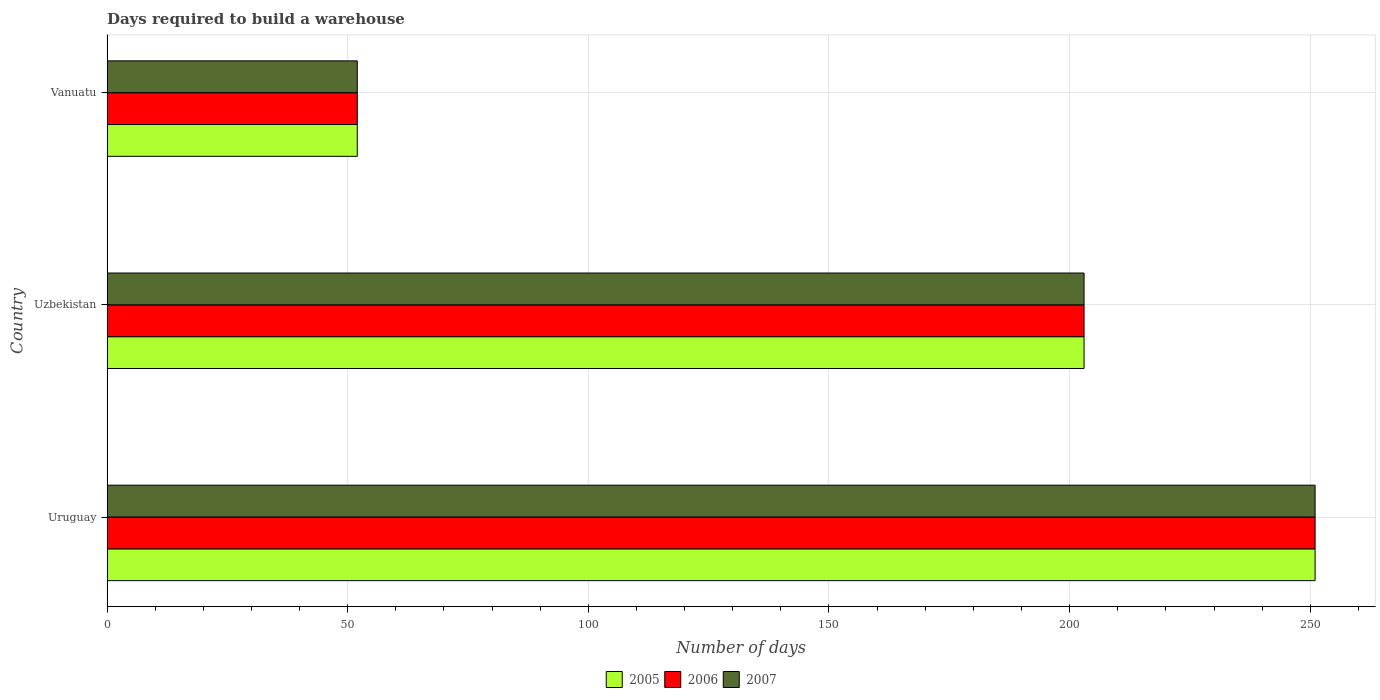How many different coloured bars are there?
Ensure brevity in your answer.  3. How many groups of bars are there?
Keep it short and to the point. 3. Are the number of bars per tick equal to the number of legend labels?
Your answer should be compact. Yes. Are the number of bars on each tick of the Y-axis equal?
Your answer should be very brief. Yes. What is the label of the 3rd group of bars from the top?
Offer a terse response. Uruguay. In how many cases, is the number of bars for a given country not equal to the number of legend labels?
Your answer should be very brief. 0. What is the days required to build a warehouse in in 2006 in Vanuatu?
Offer a terse response. 52. Across all countries, what is the maximum days required to build a warehouse in in 2006?
Keep it short and to the point. 251. In which country was the days required to build a warehouse in in 2005 maximum?
Your response must be concise. Uruguay. In which country was the days required to build a warehouse in in 2007 minimum?
Offer a terse response. Vanuatu. What is the total days required to build a warehouse in in 2006 in the graph?
Your response must be concise. 506. What is the difference between the days required to build a warehouse in in 2006 in Uruguay and that in Vanuatu?
Provide a short and direct response. 199. What is the difference between the days required to build a warehouse in in 2007 in Uruguay and the days required to build a warehouse in in 2005 in Vanuatu?
Offer a very short reply. 199. What is the average days required to build a warehouse in in 2005 per country?
Provide a succinct answer. 168.67. What is the ratio of the days required to build a warehouse in in 2005 in Uzbekistan to that in Vanuatu?
Offer a very short reply. 3.9. Is the difference between the days required to build a warehouse in in 2005 in Uzbekistan and Vanuatu greater than the difference between the days required to build a warehouse in in 2007 in Uzbekistan and Vanuatu?
Keep it short and to the point. No. What is the difference between the highest and the second highest days required to build a warehouse in in 2007?
Your answer should be compact. 48. What is the difference between the highest and the lowest days required to build a warehouse in in 2005?
Offer a terse response. 199. How many bars are there?
Your response must be concise. 9. Are all the bars in the graph horizontal?
Keep it short and to the point. Yes. How many countries are there in the graph?
Your answer should be very brief. 3. Does the graph contain any zero values?
Your answer should be very brief. No. What is the title of the graph?
Keep it short and to the point. Days required to build a warehouse. Does "2012" appear as one of the legend labels in the graph?
Keep it short and to the point. No. What is the label or title of the X-axis?
Offer a very short reply. Number of days. What is the Number of days of 2005 in Uruguay?
Make the answer very short. 251. What is the Number of days of 2006 in Uruguay?
Offer a terse response. 251. What is the Number of days of 2007 in Uruguay?
Ensure brevity in your answer.  251. What is the Number of days in 2005 in Uzbekistan?
Provide a succinct answer. 203. What is the Number of days in 2006 in Uzbekistan?
Your answer should be very brief. 203. What is the Number of days of 2007 in Uzbekistan?
Give a very brief answer. 203. What is the Number of days in 2005 in Vanuatu?
Your answer should be very brief. 52. What is the Number of days in 2006 in Vanuatu?
Your response must be concise. 52. What is the Number of days of 2007 in Vanuatu?
Make the answer very short. 52. Across all countries, what is the maximum Number of days of 2005?
Your answer should be compact. 251. Across all countries, what is the maximum Number of days of 2006?
Ensure brevity in your answer.  251. Across all countries, what is the maximum Number of days of 2007?
Your answer should be compact. 251. Across all countries, what is the minimum Number of days of 2005?
Keep it short and to the point. 52. Across all countries, what is the minimum Number of days in 2006?
Ensure brevity in your answer.  52. What is the total Number of days in 2005 in the graph?
Your answer should be compact. 506. What is the total Number of days of 2006 in the graph?
Provide a succinct answer. 506. What is the total Number of days of 2007 in the graph?
Your response must be concise. 506. What is the difference between the Number of days in 2005 in Uruguay and that in Vanuatu?
Your answer should be very brief. 199. What is the difference between the Number of days in 2006 in Uruguay and that in Vanuatu?
Your answer should be compact. 199. What is the difference between the Number of days of 2007 in Uruguay and that in Vanuatu?
Make the answer very short. 199. What is the difference between the Number of days in 2005 in Uzbekistan and that in Vanuatu?
Your response must be concise. 151. What is the difference between the Number of days in 2006 in Uzbekistan and that in Vanuatu?
Make the answer very short. 151. What is the difference between the Number of days of 2007 in Uzbekistan and that in Vanuatu?
Make the answer very short. 151. What is the difference between the Number of days in 2005 in Uruguay and the Number of days in 2006 in Uzbekistan?
Keep it short and to the point. 48. What is the difference between the Number of days in 2005 in Uruguay and the Number of days in 2007 in Uzbekistan?
Offer a terse response. 48. What is the difference between the Number of days of 2006 in Uruguay and the Number of days of 2007 in Uzbekistan?
Offer a very short reply. 48. What is the difference between the Number of days in 2005 in Uruguay and the Number of days in 2006 in Vanuatu?
Ensure brevity in your answer.  199. What is the difference between the Number of days of 2005 in Uruguay and the Number of days of 2007 in Vanuatu?
Your response must be concise. 199. What is the difference between the Number of days in 2006 in Uruguay and the Number of days in 2007 in Vanuatu?
Ensure brevity in your answer.  199. What is the difference between the Number of days of 2005 in Uzbekistan and the Number of days of 2006 in Vanuatu?
Your response must be concise. 151. What is the difference between the Number of days in 2005 in Uzbekistan and the Number of days in 2007 in Vanuatu?
Your response must be concise. 151. What is the difference between the Number of days of 2006 in Uzbekistan and the Number of days of 2007 in Vanuatu?
Your response must be concise. 151. What is the average Number of days in 2005 per country?
Your response must be concise. 168.67. What is the average Number of days in 2006 per country?
Provide a short and direct response. 168.67. What is the average Number of days of 2007 per country?
Keep it short and to the point. 168.67. What is the difference between the Number of days in 2005 and Number of days in 2006 in Uruguay?
Your answer should be very brief. 0. What is the difference between the Number of days of 2006 and Number of days of 2007 in Uruguay?
Offer a very short reply. 0. What is the ratio of the Number of days in 2005 in Uruguay to that in Uzbekistan?
Your response must be concise. 1.24. What is the ratio of the Number of days in 2006 in Uruguay to that in Uzbekistan?
Your answer should be very brief. 1.24. What is the ratio of the Number of days of 2007 in Uruguay to that in Uzbekistan?
Your response must be concise. 1.24. What is the ratio of the Number of days of 2005 in Uruguay to that in Vanuatu?
Offer a very short reply. 4.83. What is the ratio of the Number of days in 2006 in Uruguay to that in Vanuatu?
Give a very brief answer. 4.83. What is the ratio of the Number of days of 2007 in Uruguay to that in Vanuatu?
Offer a very short reply. 4.83. What is the ratio of the Number of days in 2005 in Uzbekistan to that in Vanuatu?
Provide a succinct answer. 3.9. What is the ratio of the Number of days of 2006 in Uzbekistan to that in Vanuatu?
Provide a succinct answer. 3.9. What is the ratio of the Number of days in 2007 in Uzbekistan to that in Vanuatu?
Offer a very short reply. 3.9. What is the difference between the highest and the second highest Number of days of 2007?
Keep it short and to the point. 48. What is the difference between the highest and the lowest Number of days of 2005?
Ensure brevity in your answer.  199. What is the difference between the highest and the lowest Number of days of 2006?
Your answer should be very brief. 199. What is the difference between the highest and the lowest Number of days of 2007?
Make the answer very short. 199. 